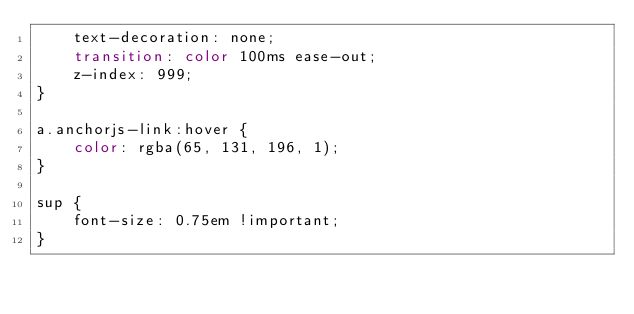<code> <loc_0><loc_0><loc_500><loc_500><_CSS_>    text-decoration: none;
    transition: color 100ms ease-out;
    z-index: 999;
}

a.anchorjs-link:hover {
    color: rgba(65, 131, 196, 1);
}

sup {
    font-size: 0.75em !important;
}
</code> 